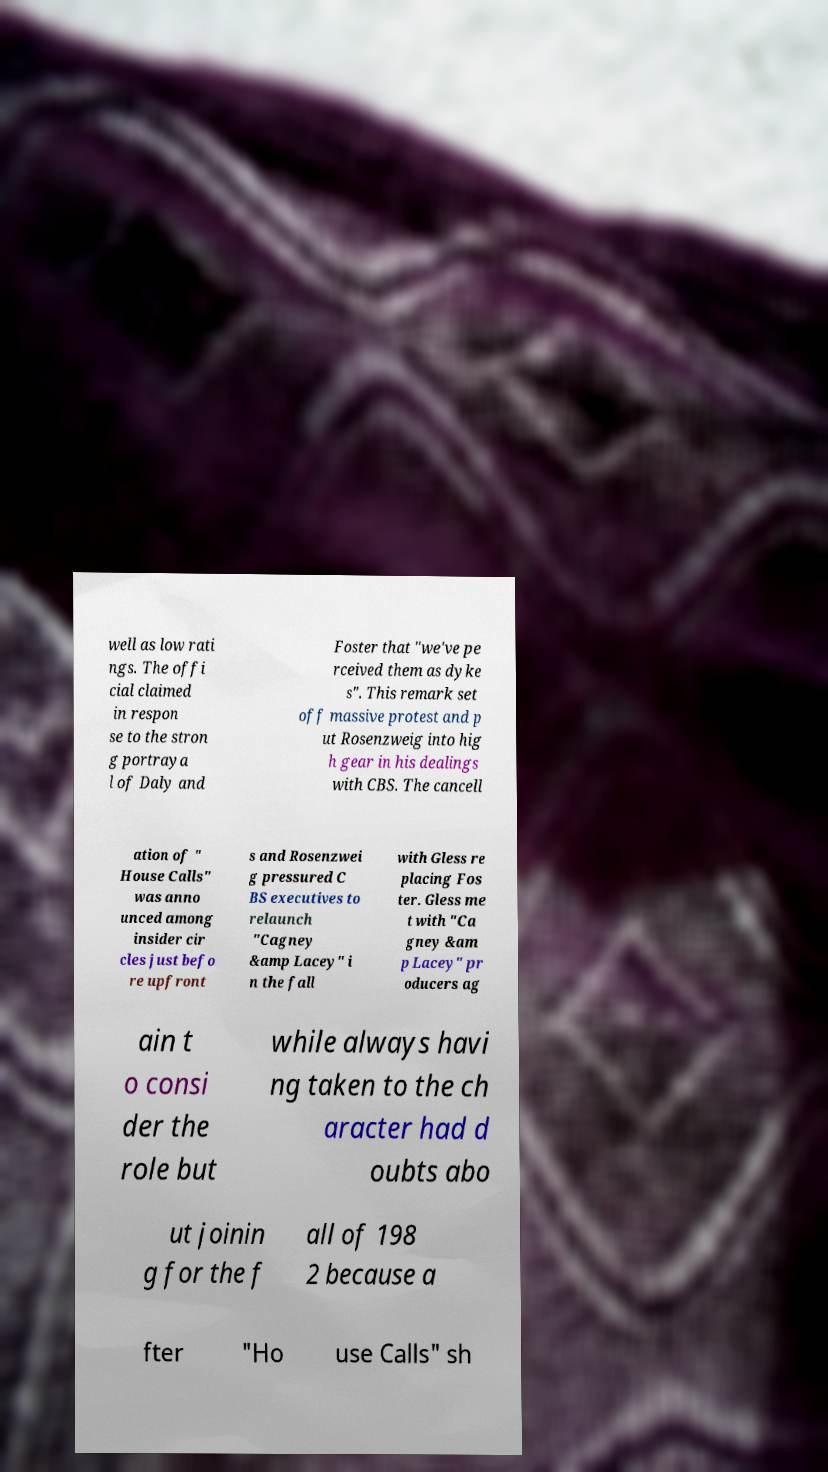Could you extract and type out the text from this image? well as low rati ngs. The offi cial claimed in respon se to the stron g portraya l of Daly and Foster that "we've pe rceived them as dyke s". This remark set off massive protest and p ut Rosenzweig into hig h gear in his dealings with CBS. The cancell ation of " House Calls" was anno unced among insider cir cles just befo re upfront s and Rosenzwei g pressured C BS executives to relaunch "Cagney &amp Lacey" i n the fall with Gless re placing Fos ter. Gless me t with "Ca gney &am p Lacey" pr oducers ag ain t o consi der the role but while always havi ng taken to the ch aracter had d oubts abo ut joinin g for the f all of 198 2 because a fter "Ho use Calls" sh 